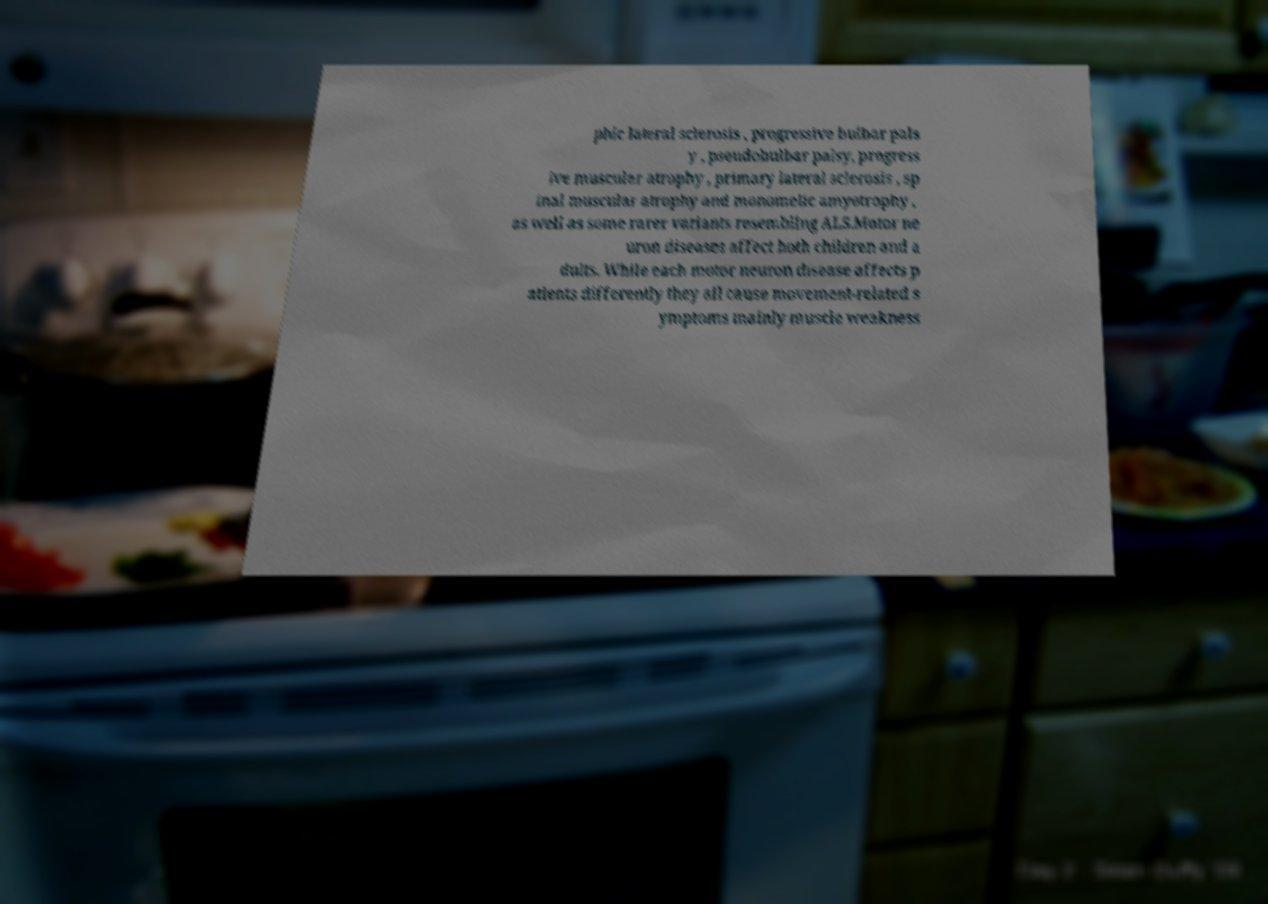I need the written content from this picture converted into text. Can you do that? phic lateral sclerosis , progressive bulbar pals y , pseudobulbar palsy, progress ive muscular atrophy , primary lateral sclerosis , sp inal muscular atrophy and monomelic amyotrophy , as well as some rarer variants resembling ALS.Motor ne uron diseases affect both children and a dults. While each motor neuron disease affects p atients differently they all cause movement-related s ymptoms mainly muscle weakness 